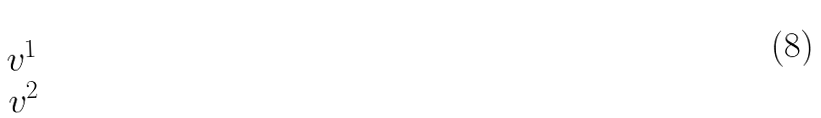Convert formula to latex. <formula><loc_0><loc_0><loc_500><loc_500>\begin{matrix} v ^ { 1 } \\ v ^ { 2 } \end{matrix}</formula> 